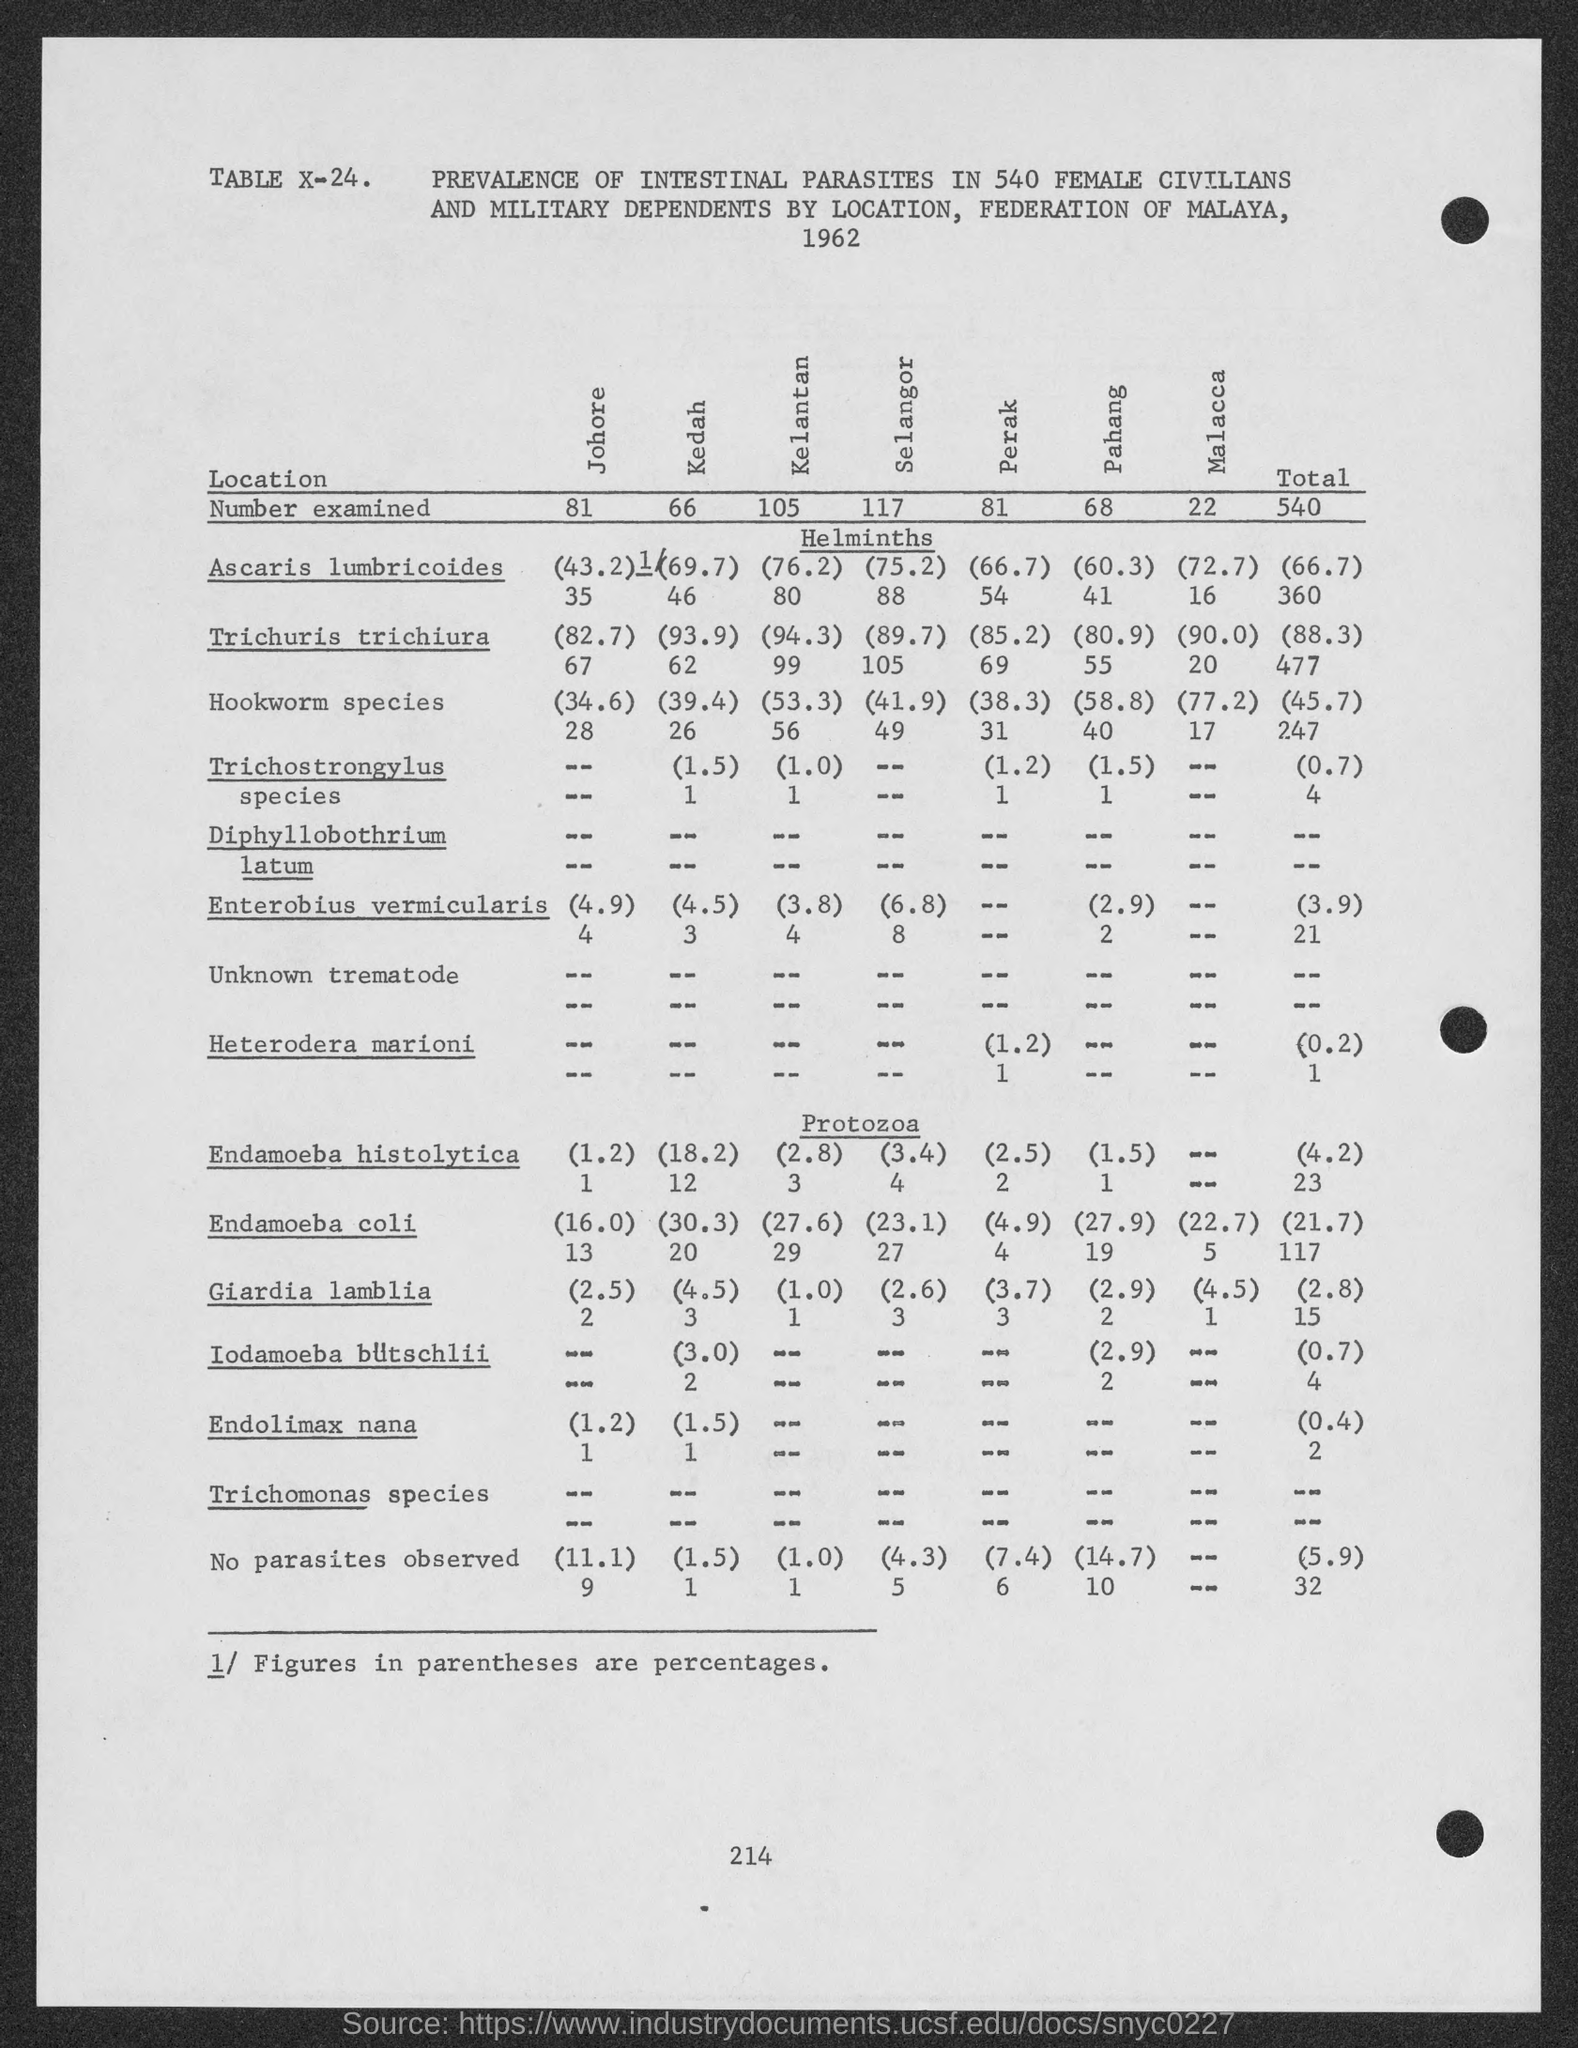Mention a couple of crucial points in this snapshot. The number at the bottom of the page is 214. 